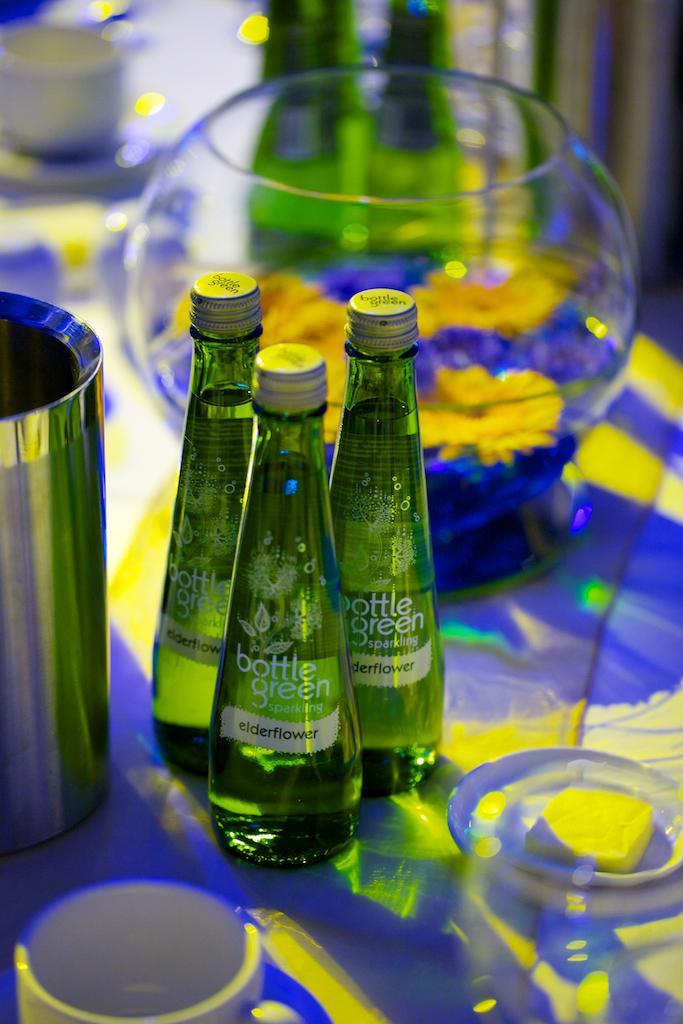Describe this image in one or two sentences. In this image i can see three bottle, few glasses and a pot on a table. 